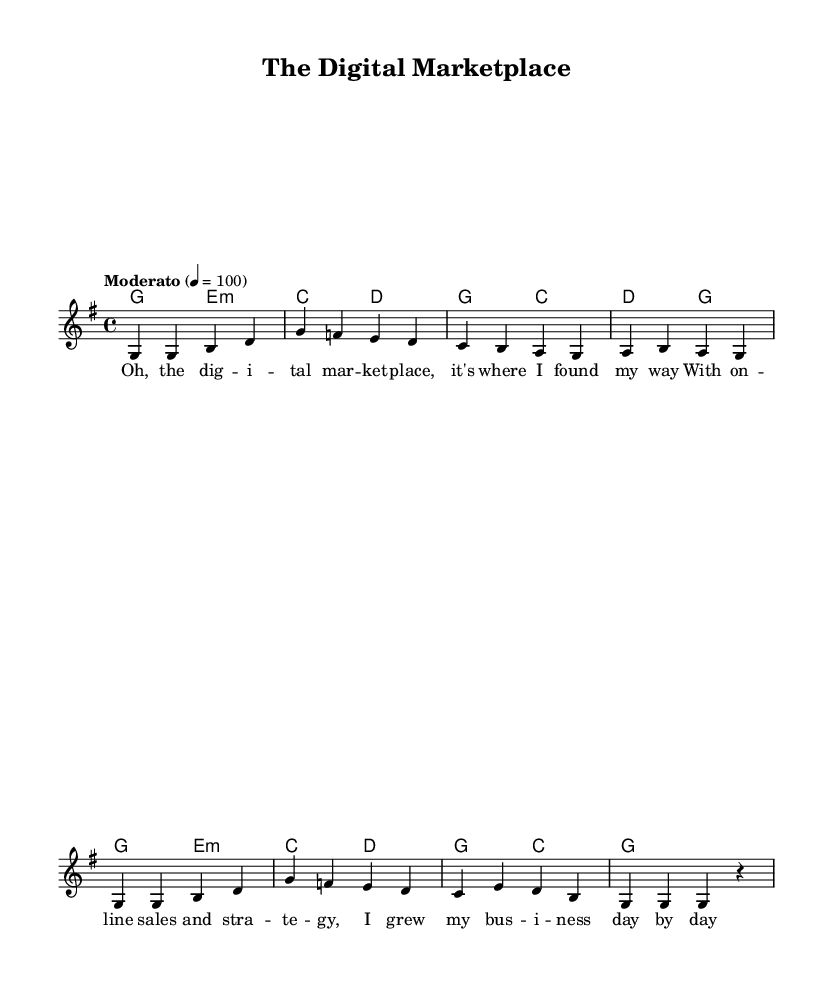What is the key signature of this music? The key signature shows one sharp, which indicates that the key is G major.
Answer: G major What is the time signature of this music? The time signature is found at the beginning of the sheet music, indicated by the numbers written as 4 over 4, which means it has four beats per measure.
Answer: 4/4 What is the tempo marking of this music? The tempo marking is provided at the start, indicating a moderate speed of 100 beats per minute (bpm).
Answer: Moderato How many measures are in the melody? By counting the divided segments, we see that there are a total of eight measures in the melody part of the music.
Answer: Eight What type of chord is represented in the first measure? The chord in the first measure consists of the notes G, which is a major chord (root, third, and fifth).
Answer: Major Describe the overall theme of the lyrics. The lyrics reflect a narrative about success in online sales and business growth through the digital marketplace.
Answer: E-commerce What does the song reflect about traditional folk music? This piece adapts the structure and storytelling characteristic of folk songs while incorporating modern e-commerce themes, showing how traditional forms can evolve.
Answer: Adaptation 